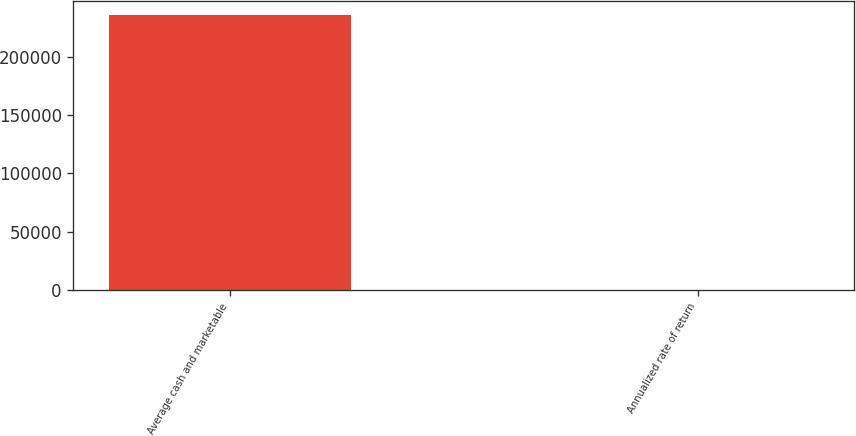Convert chart to OTSL. <chart><loc_0><loc_0><loc_500><loc_500><bar_chart><fcel>Average cash and marketable<fcel>Annualized rate of return<nl><fcel>235871<fcel>2.2<nl></chart> 